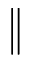Convert formula to latex. <formula><loc_0><loc_0><loc_500><loc_500>\|</formula> 